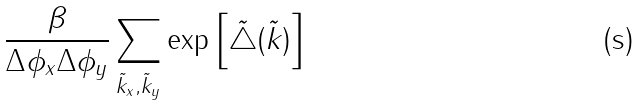Convert formula to latex. <formula><loc_0><loc_0><loc_500><loc_500>\frac { \beta } { \Delta \phi _ { x } \Delta \phi _ { y } } \sum _ { { \tilde { k } } _ { x } , { \tilde { k } } _ { y } } \exp \left [ { \tilde { \triangle } } ( { \tilde { k } } ) \right ]</formula> 